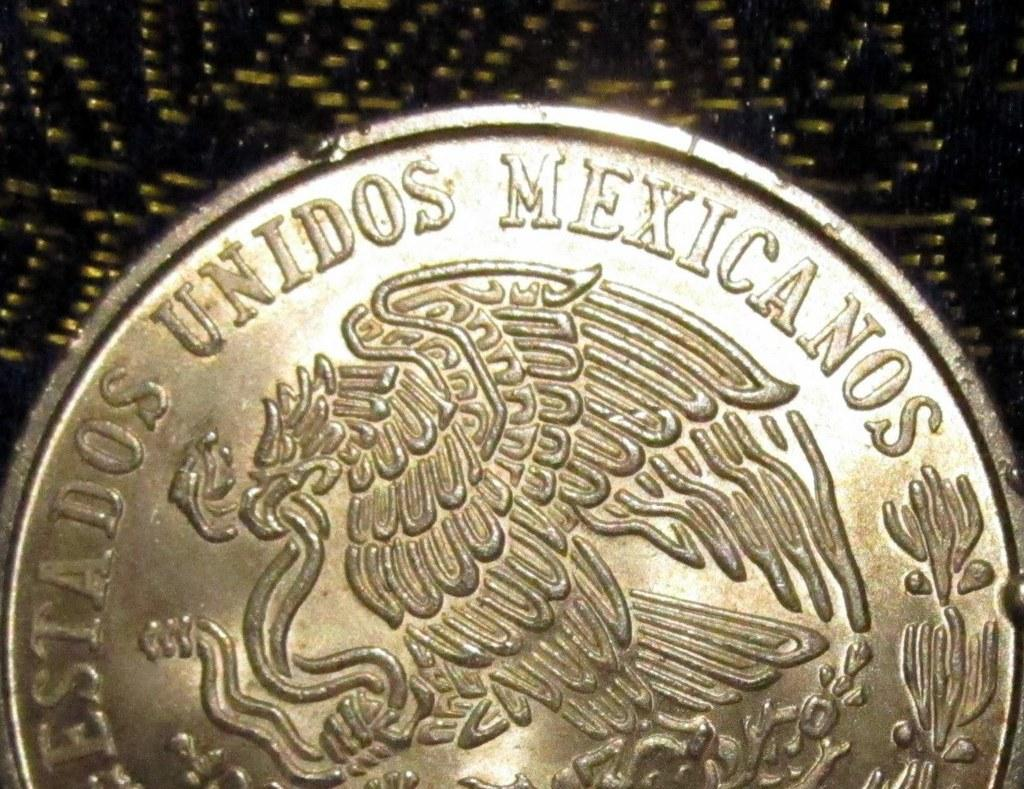What object is present in the image that has monetary value? There is a coin in the image. What is written on the coin? The coin has text written on it. What type of cap can be seen on the dolls in the image? There are no dolls present in the image, so there is no cap to be seen. 